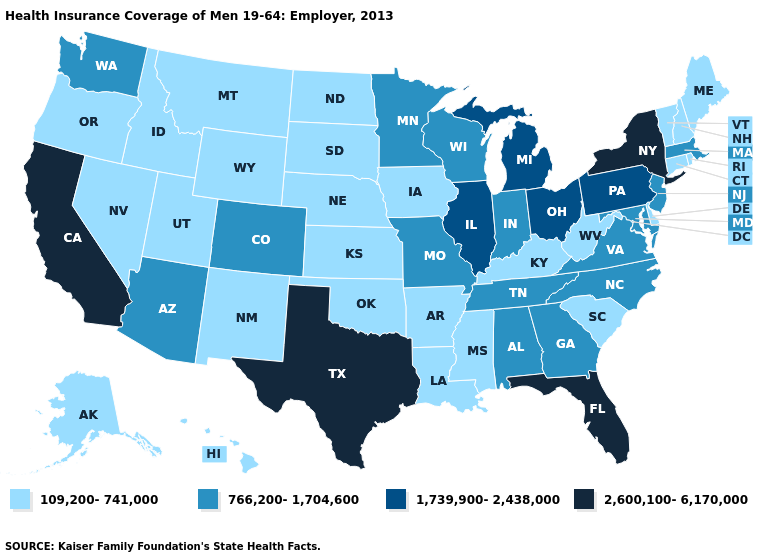What is the value of Rhode Island?
Quick response, please. 109,200-741,000. Does Colorado have the lowest value in the USA?
Write a very short answer. No. What is the value of Michigan?
Answer briefly. 1,739,900-2,438,000. Does Oregon have the lowest value in the West?
Quick response, please. Yes. Does Oklahoma have the same value as Missouri?
Write a very short answer. No. What is the lowest value in states that border Mississippi?
Be succinct. 109,200-741,000. Name the states that have a value in the range 109,200-741,000?
Keep it brief. Alaska, Arkansas, Connecticut, Delaware, Hawaii, Idaho, Iowa, Kansas, Kentucky, Louisiana, Maine, Mississippi, Montana, Nebraska, Nevada, New Hampshire, New Mexico, North Dakota, Oklahoma, Oregon, Rhode Island, South Carolina, South Dakota, Utah, Vermont, West Virginia, Wyoming. What is the value of West Virginia?
Write a very short answer. 109,200-741,000. Name the states that have a value in the range 1,739,900-2,438,000?
Write a very short answer. Illinois, Michigan, Ohio, Pennsylvania. Does Maryland have the lowest value in the USA?
Write a very short answer. No. Which states have the lowest value in the USA?
Quick response, please. Alaska, Arkansas, Connecticut, Delaware, Hawaii, Idaho, Iowa, Kansas, Kentucky, Louisiana, Maine, Mississippi, Montana, Nebraska, Nevada, New Hampshire, New Mexico, North Dakota, Oklahoma, Oregon, Rhode Island, South Carolina, South Dakota, Utah, Vermont, West Virginia, Wyoming. What is the value of Illinois?
Give a very brief answer. 1,739,900-2,438,000. Name the states that have a value in the range 1,739,900-2,438,000?
Keep it brief. Illinois, Michigan, Ohio, Pennsylvania. What is the lowest value in the MidWest?
Be succinct. 109,200-741,000. Name the states that have a value in the range 2,600,100-6,170,000?
Quick response, please. California, Florida, New York, Texas. 